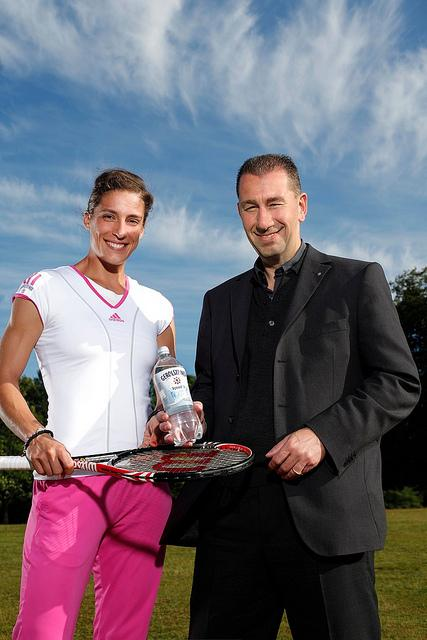What corporation made the shirt the woman is wearing?

Choices:
A) adidas
B) new balance
C) hanes
D) everlast adidas 